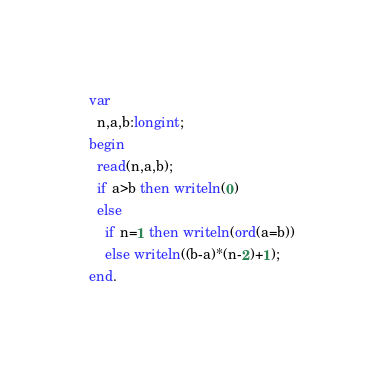Convert code to text. <code><loc_0><loc_0><loc_500><loc_500><_Pascal_>var
  n,a,b:longint;
begin
  read(n,a,b);
  if a>b then writeln(0)
  else
    if n=1 then writeln(ord(a=b))
    else writeln((b-a)*(n-2)+1);
end.</code> 